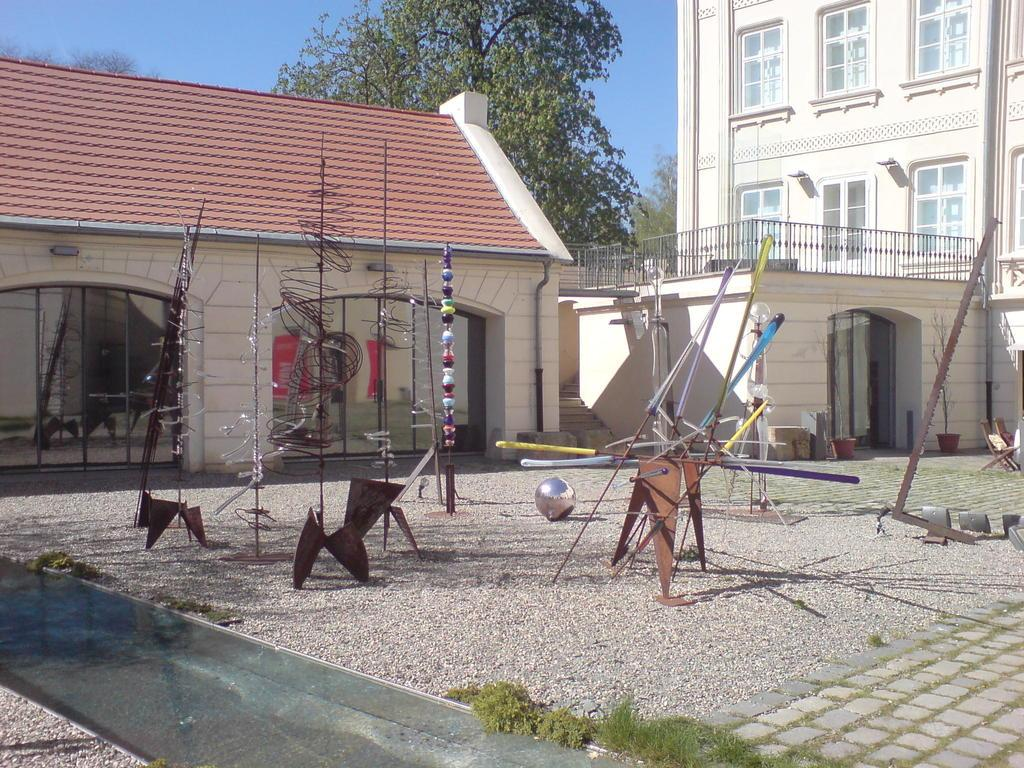What can be seen on the ground in the image? There are sticks and objects on the ground in the image. What type of plants are visible in the image? There are house plants in the image. What structures can be seen in the image? There are buildings in the image. What is visible in the background of the image? There are trees and the sky in the background of the image. How does the sea blow in the image? There is no sea present in the image, so it cannot blow. What type of answer can be seen in the image? There is no answer visible in the image; it contains sticks, objects, house plants, buildings, trees, and the sky. 